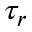Convert formula to latex. <formula><loc_0><loc_0><loc_500><loc_500>\tau _ { r }</formula> 